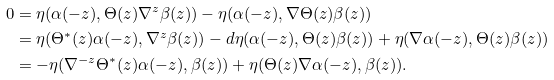<formula> <loc_0><loc_0><loc_500><loc_500>0 & = \eta ( \alpha ( - z ) , \Theta ( z ) \nabla ^ { z } \beta ( z ) ) - \eta ( \alpha ( - z ) , \nabla \Theta ( z ) \beta ( z ) ) \\ & = \eta ( \Theta ^ { * } ( z ) \alpha ( - z ) , \nabla ^ { z } \beta ( z ) ) - d \eta ( \alpha ( - z ) , \Theta ( z ) \beta ( z ) ) + \eta ( \nabla \alpha ( - z ) , \Theta ( z ) \beta ( z ) ) \\ & = - \eta ( \nabla ^ { - z } \Theta ^ { * } ( z ) \alpha ( - z ) , \beta ( z ) ) + \eta ( \Theta ( z ) \nabla \alpha ( - z ) , \beta ( z ) ) .</formula> 